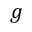<formula> <loc_0><loc_0><loc_500><loc_500>g</formula> 